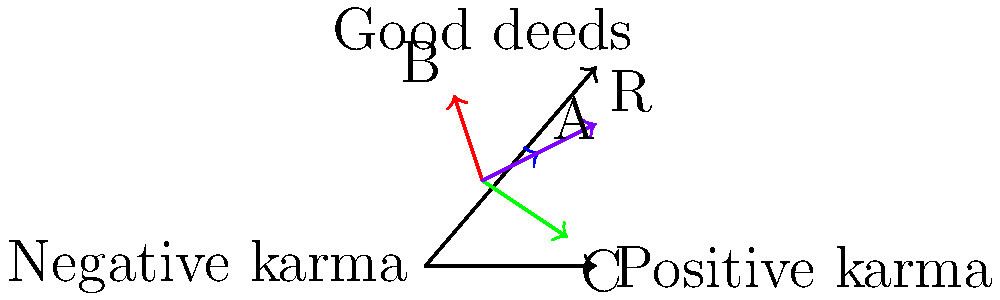In the context of karma accumulation, consider three actions represented by vectors A, B, and C in the graph. Vector A represents a good deed with positive karma, vector B represents a negative action, and vector C represents another positive action. Calculate the resultant vector R, which represents the overall karma accumulated. What is the magnitude of the resultant karma vector R? To solve this problem, we need to follow these steps:

1. Identify the components of each vector:
   A = (2, 1)
   B = (-1, 3)
   C = (3, -2)

2. Add the vectors to find the resultant R:
   R = A + B + C
   R = (2, 1) + (-1, 3) + (3, -2)
   R = (2 - 1 + 3, 1 + 3 - 2)
   R = (4, 2)

3. Calculate the magnitude of R using the Pythagorean theorem:
   $$|R| = \sqrt{x^2 + y^2}$$
   $$|R| = \sqrt{4^2 + 2^2}$$
   $$|R| = \sqrt{16 + 4}$$
   $$|R| = \sqrt{20}$$
   $$|R| = 2\sqrt{5}$$

Therefore, the magnitude of the resultant karma vector R is $2\sqrt{5}$.
Answer: $2\sqrt{5}$ 